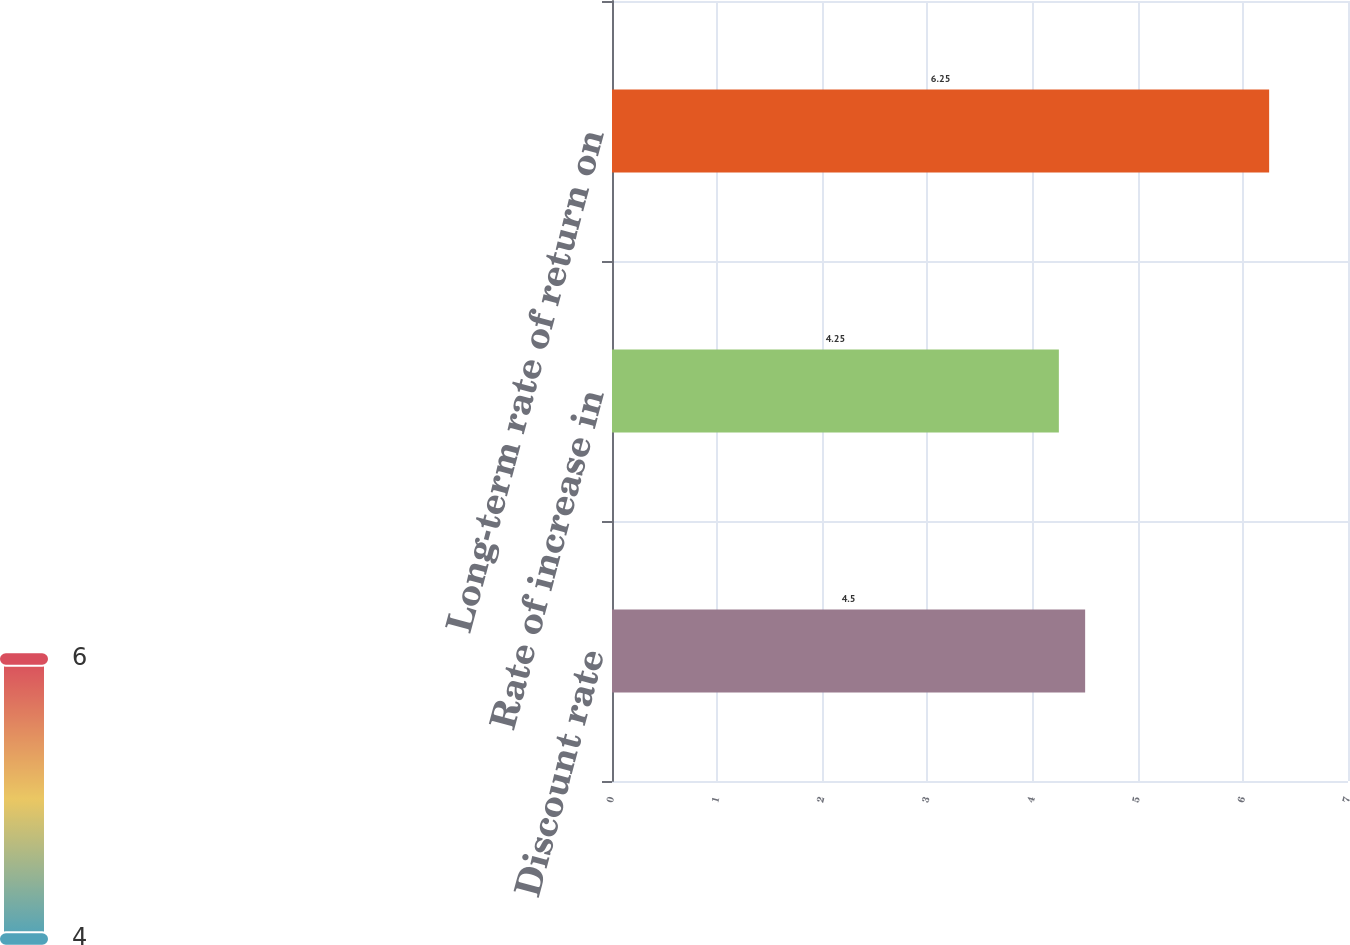Convert chart. <chart><loc_0><loc_0><loc_500><loc_500><bar_chart><fcel>Discount rate<fcel>Rate of increase in<fcel>Long-term rate of return on<nl><fcel>4.5<fcel>4.25<fcel>6.25<nl></chart> 